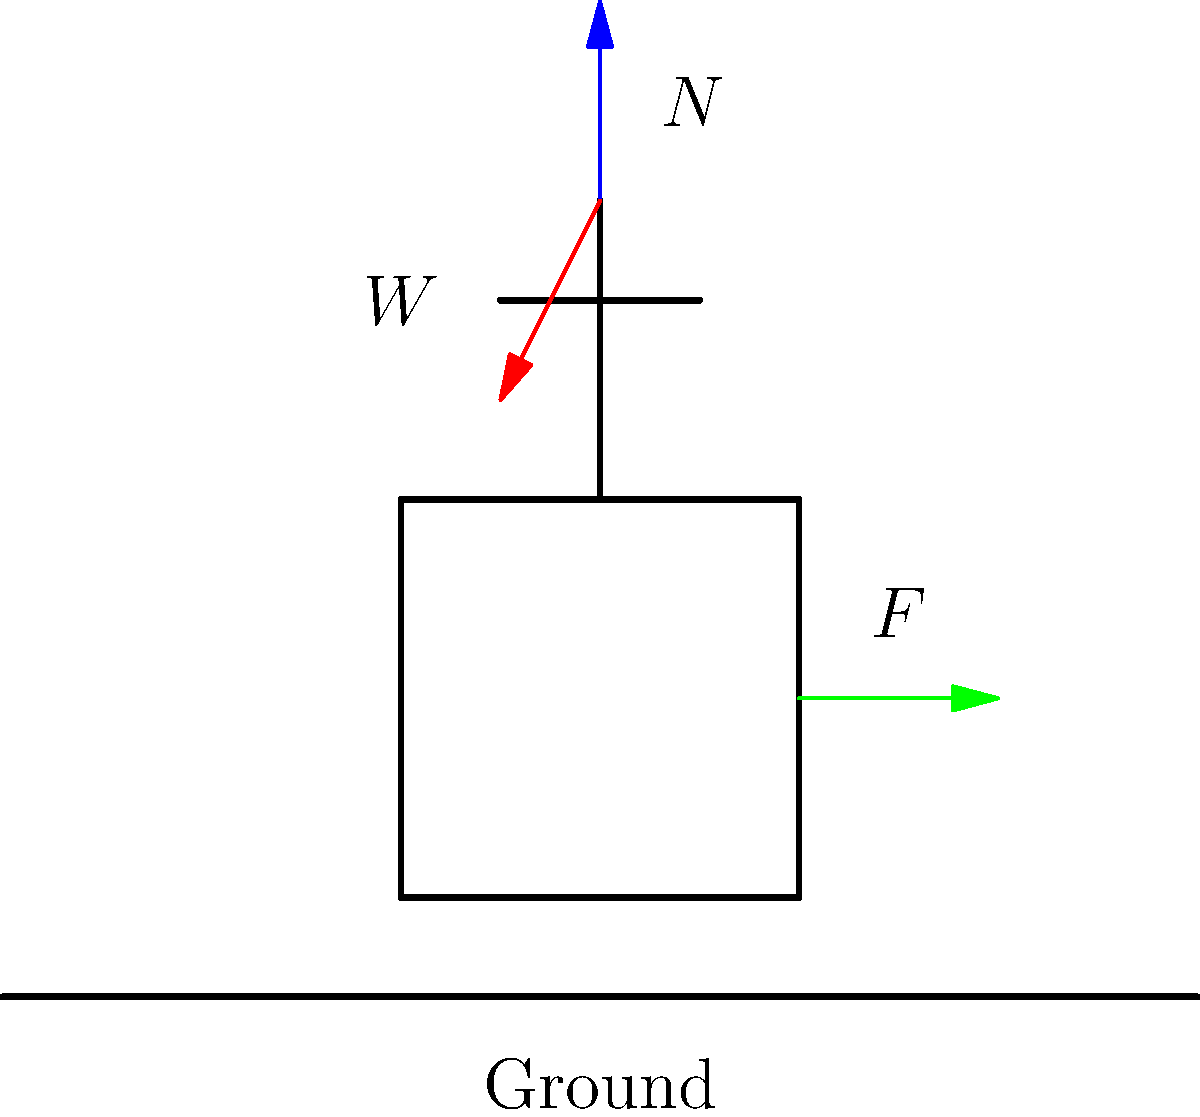A senior resident is using a walker for support. In the free body diagram shown, identify the magnitude and direction of the applied force $F$ required to maintain equilibrium if the resident's weight $W$ is 700 N and the normal force $N$ from the ground is 700 N. Assume the applied force is horizontal. To solve this problem, we'll use the principles of static equilibrium. For a body to be in equilibrium, the sum of all forces must be zero in both horizontal and vertical directions.

Step 1: Analyze vertical forces
$$\sum F_y = 0$$
$$N - W = 0$$
$$700 N - 700 N = 0$$
This confirms vertical equilibrium.

Step 2: Analyze horizontal forces
Since there's only one horizontal force (the applied force F), it must be zero for horizontal equilibrium.
$$\sum F_x = 0$$
$$F = 0$$

Step 3: Consider rotational equilibrium
The applied force F creates a clockwise moment around the point of contact with the ground, which must be balanced by the weight W to prevent tipping.

However, since F = 0, there is no moment to balance, and the system is in rotational equilibrium without any additional force.

Therefore, in this idealized scenario, the applied force F required to maintain equilibrium is 0 N in the horizontal direction.
Answer: 0 N, horizontal 